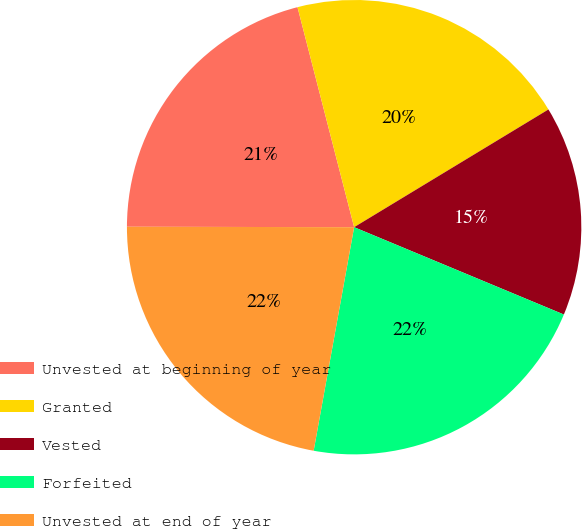Convert chart to OTSL. <chart><loc_0><loc_0><loc_500><loc_500><pie_chart><fcel>Unvested at beginning of year<fcel>Granted<fcel>Vested<fcel>Forfeited<fcel>Unvested at end of year<nl><fcel>20.96%<fcel>20.34%<fcel>14.95%<fcel>21.57%<fcel>22.18%<nl></chart> 